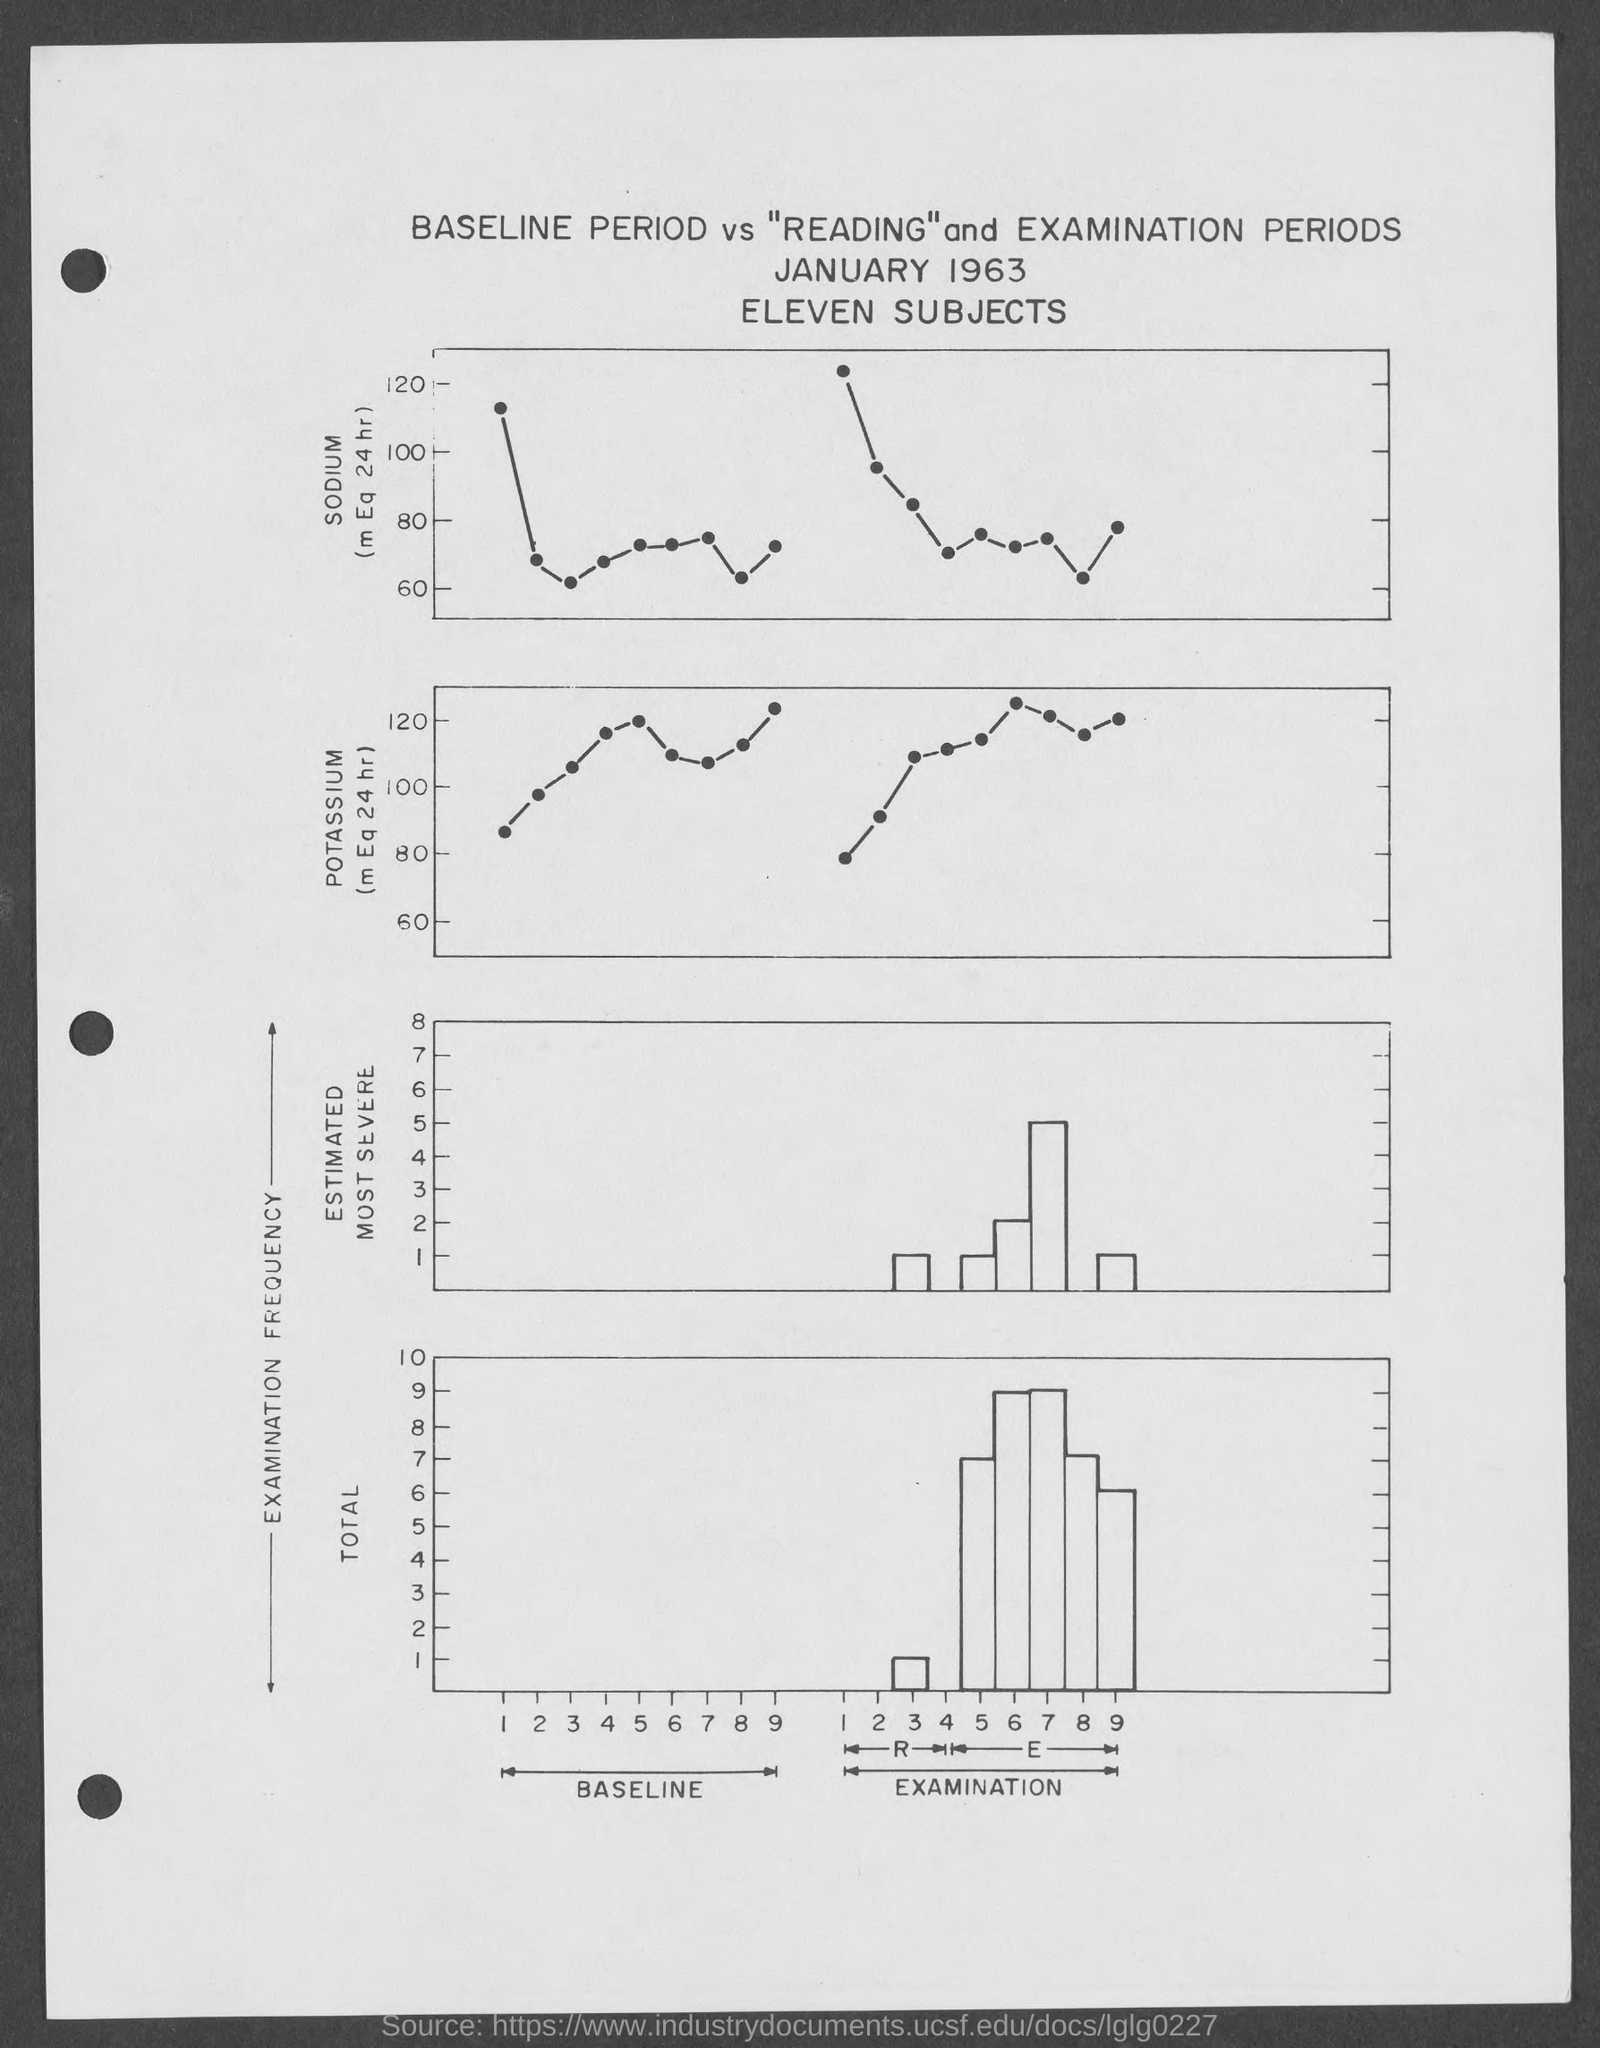Specify some key components in this picture. The maximum value depicted on the y-axis of the top section of the graph is 120. The maximum total value of the y-axis on the graph provided at the bottom of the page is 10. The title of the page gives the information that January 1963 is the month and year. In the top graph, the chemical element marked at the Y-axis is sodium. The first part of the x-axis represents the baseline, which is a reference point for comparison against the other values on the chart. 